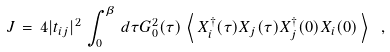Convert formula to latex. <formula><loc_0><loc_0><loc_500><loc_500>J \, = \, 4 | t _ { i j } | ^ { 2 } \, \int _ { 0 } ^ { \beta } \, d \tau G _ { 0 } ^ { 2 } ( \tau ) \, \left < \, X ^ { \dagger } _ { i } ( \tau ) X _ { j } ( \tau ) X ^ { \dagger } _ { j } ( 0 ) X _ { i } ( 0 ) \, \right > \ ,</formula> 